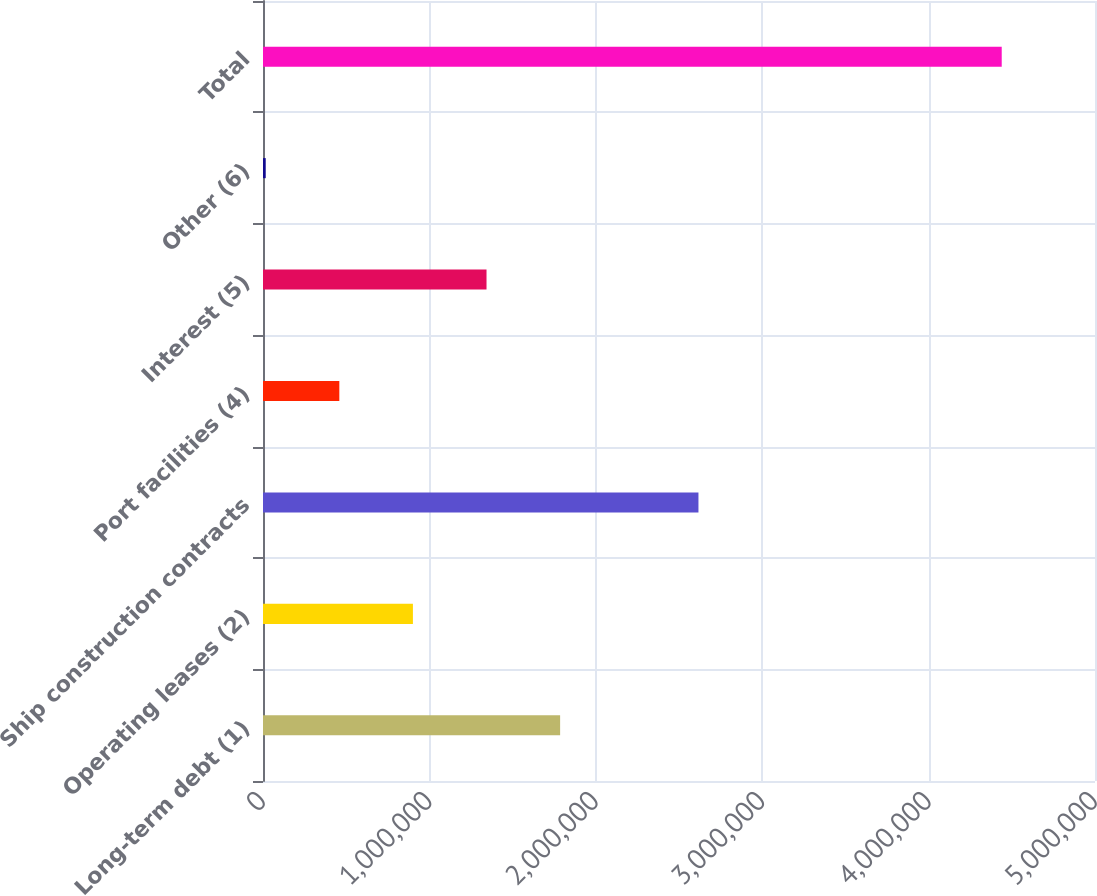Convert chart to OTSL. <chart><loc_0><loc_0><loc_500><loc_500><bar_chart><fcel>Long-term debt (1)<fcel>Operating leases (2)<fcel>Ship construction contracts<fcel>Port facilities (4)<fcel>Interest (5)<fcel>Other (6)<fcel>Total<nl><fcel>1.78558e+06<fcel>900969<fcel>2.6169e+06<fcel>458662<fcel>1.34328e+06<fcel>16355<fcel>4.43943e+06<nl></chart> 